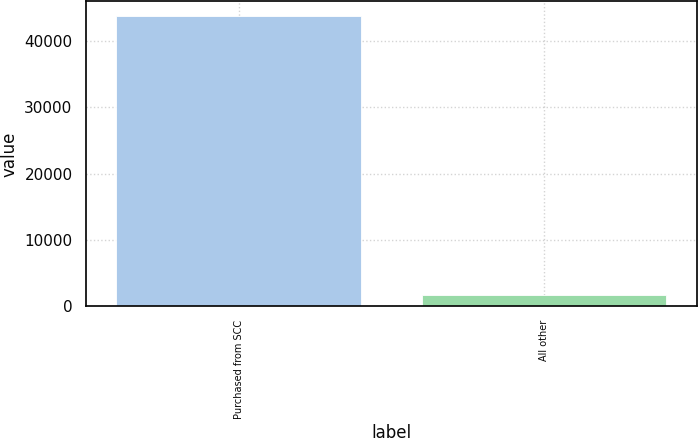Convert chart to OTSL. <chart><loc_0><loc_0><loc_500><loc_500><bar_chart><fcel>Purchased from SCC<fcel>All other<nl><fcel>43769<fcel>1632<nl></chart> 